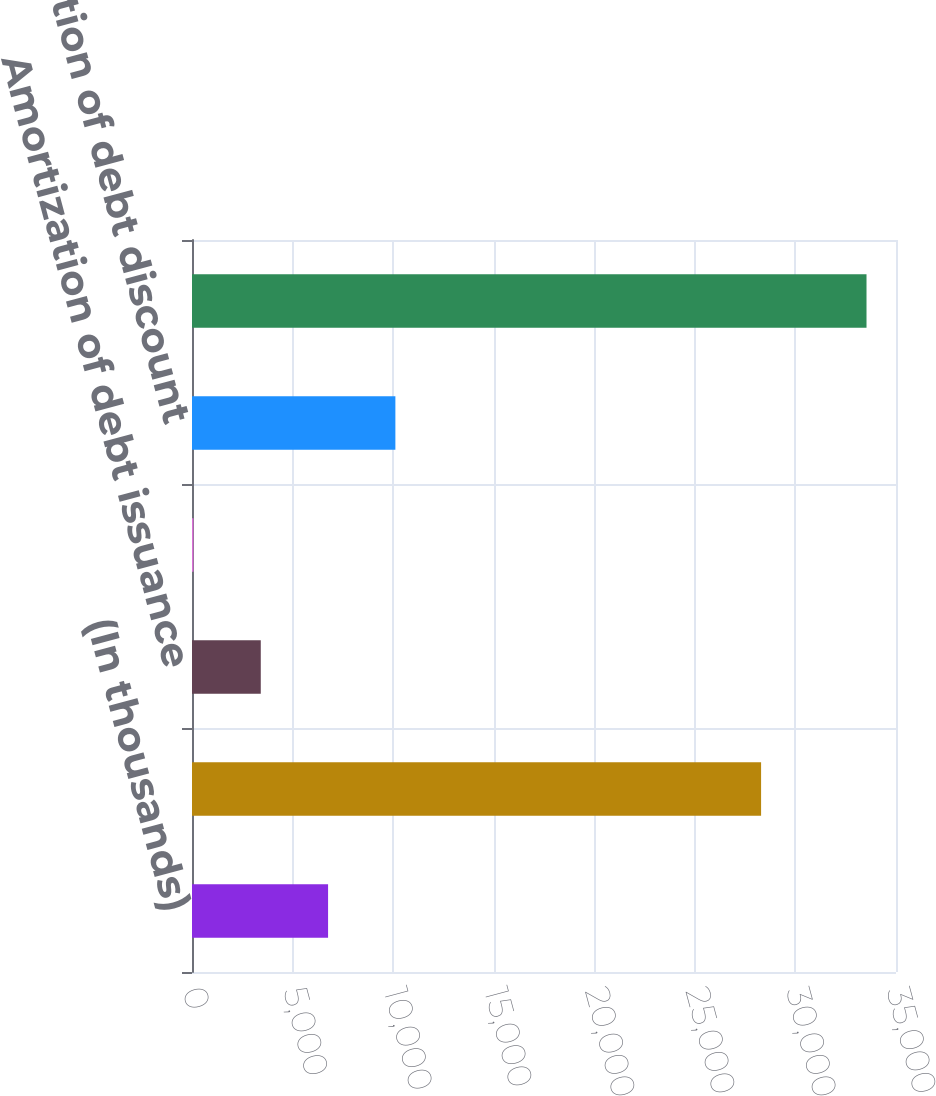Convert chart to OTSL. <chart><loc_0><loc_0><loc_500><loc_500><bar_chart><fcel>(In thousands)<fcel>Contractual coupon interest<fcel>Amortization of debt issuance<fcel>Amortization of embedded<fcel>Amortization of debt discount<fcel>Total interest expense related<nl><fcel>6765.2<fcel>28293<fcel>3419.1<fcel>73<fcel>10111.3<fcel>33534<nl></chart> 